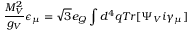<formula> <loc_0><loc_0><loc_500><loc_500>\frac { M _ { V } ^ { 2 } } { g _ { V } } \epsilon _ { \mu } = \sqrt { 3 } e _ { Q } \int d ^ { 4 } q T r [ \Psi _ { V } i \gamma _ { \mu } ]</formula> 